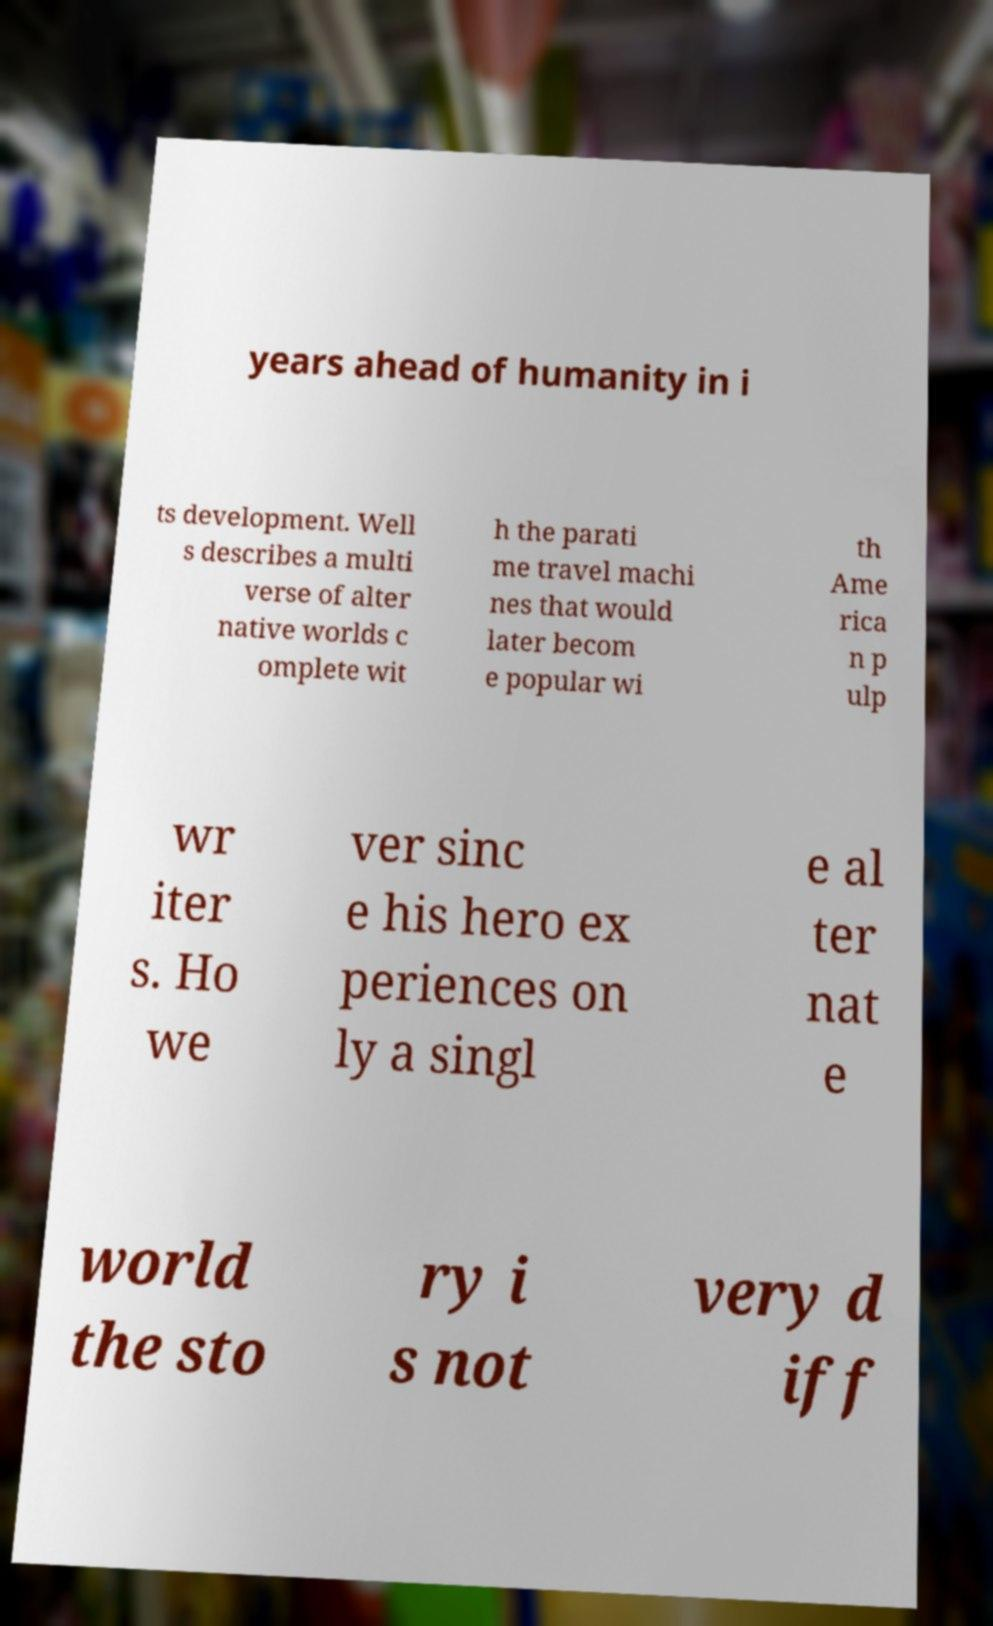Could you extract and type out the text from this image? years ahead of humanity in i ts development. Well s describes a multi verse of alter native worlds c omplete wit h the parati me travel machi nes that would later becom e popular wi th Ame rica n p ulp wr iter s. Ho we ver sinc e his hero ex periences on ly a singl e al ter nat e world the sto ry i s not very d iff 